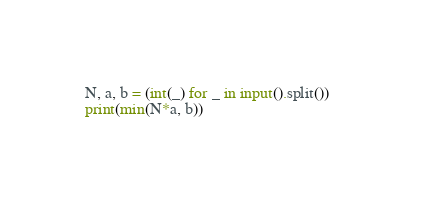Convert code to text. <code><loc_0><loc_0><loc_500><loc_500><_Python_>N, a, b = (int(_) for _ in input().split())  
print(min(N*a, b))</code> 